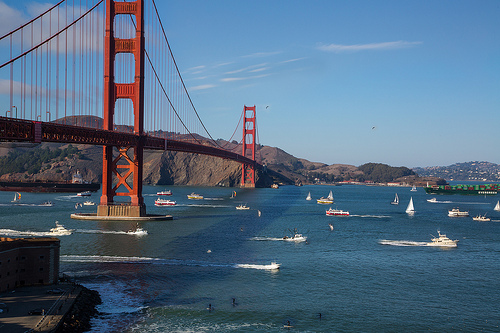<image>
Is there a ship in the water? Yes. The ship is contained within or inside the water, showing a containment relationship. 